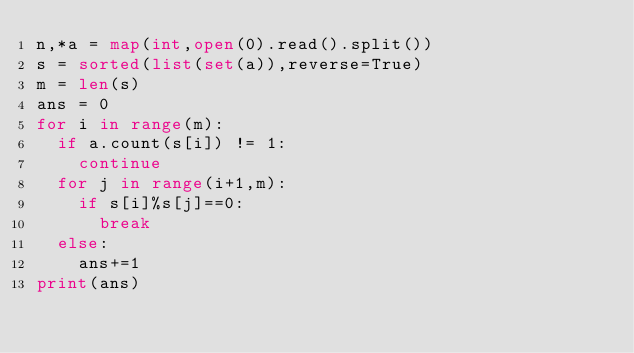Convert code to text. <code><loc_0><loc_0><loc_500><loc_500><_Python_>n,*a = map(int,open(0).read().split())
s = sorted(list(set(a)),reverse=True)
m = len(s)
ans = 0
for i in range(m):
  if a.count(s[i]) != 1:
    continue
  for j in range(i+1,m):
    if s[i]%s[j]==0:
      break
  else:
    ans+=1
print(ans)</code> 